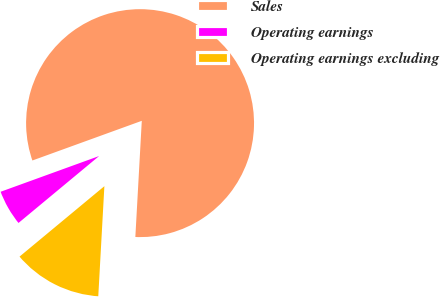Convert chart. <chart><loc_0><loc_0><loc_500><loc_500><pie_chart><fcel>Sales<fcel>Operating earnings<fcel>Operating earnings excluding<nl><fcel>81.42%<fcel>5.49%<fcel>13.09%<nl></chart> 